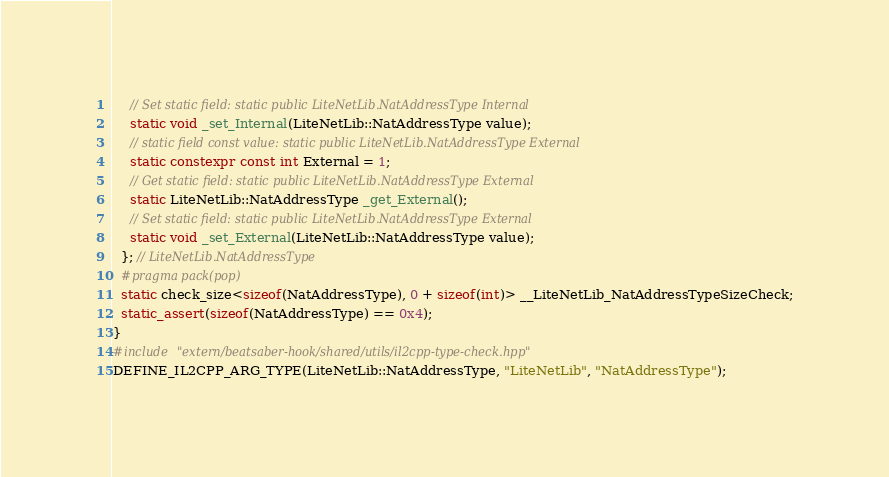<code> <loc_0><loc_0><loc_500><loc_500><_C++_>    // Set static field: static public LiteNetLib.NatAddressType Internal
    static void _set_Internal(LiteNetLib::NatAddressType value);
    // static field const value: static public LiteNetLib.NatAddressType External
    static constexpr const int External = 1;
    // Get static field: static public LiteNetLib.NatAddressType External
    static LiteNetLib::NatAddressType _get_External();
    // Set static field: static public LiteNetLib.NatAddressType External
    static void _set_External(LiteNetLib::NatAddressType value);
  }; // LiteNetLib.NatAddressType
  #pragma pack(pop)
  static check_size<sizeof(NatAddressType), 0 + sizeof(int)> __LiteNetLib_NatAddressTypeSizeCheck;
  static_assert(sizeof(NatAddressType) == 0x4);
}
#include "extern/beatsaber-hook/shared/utils/il2cpp-type-check.hpp"
DEFINE_IL2CPP_ARG_TYPE(LiteNetLib::NatAddressType, "LiteNetLib", "NatAddressType");
</code> 